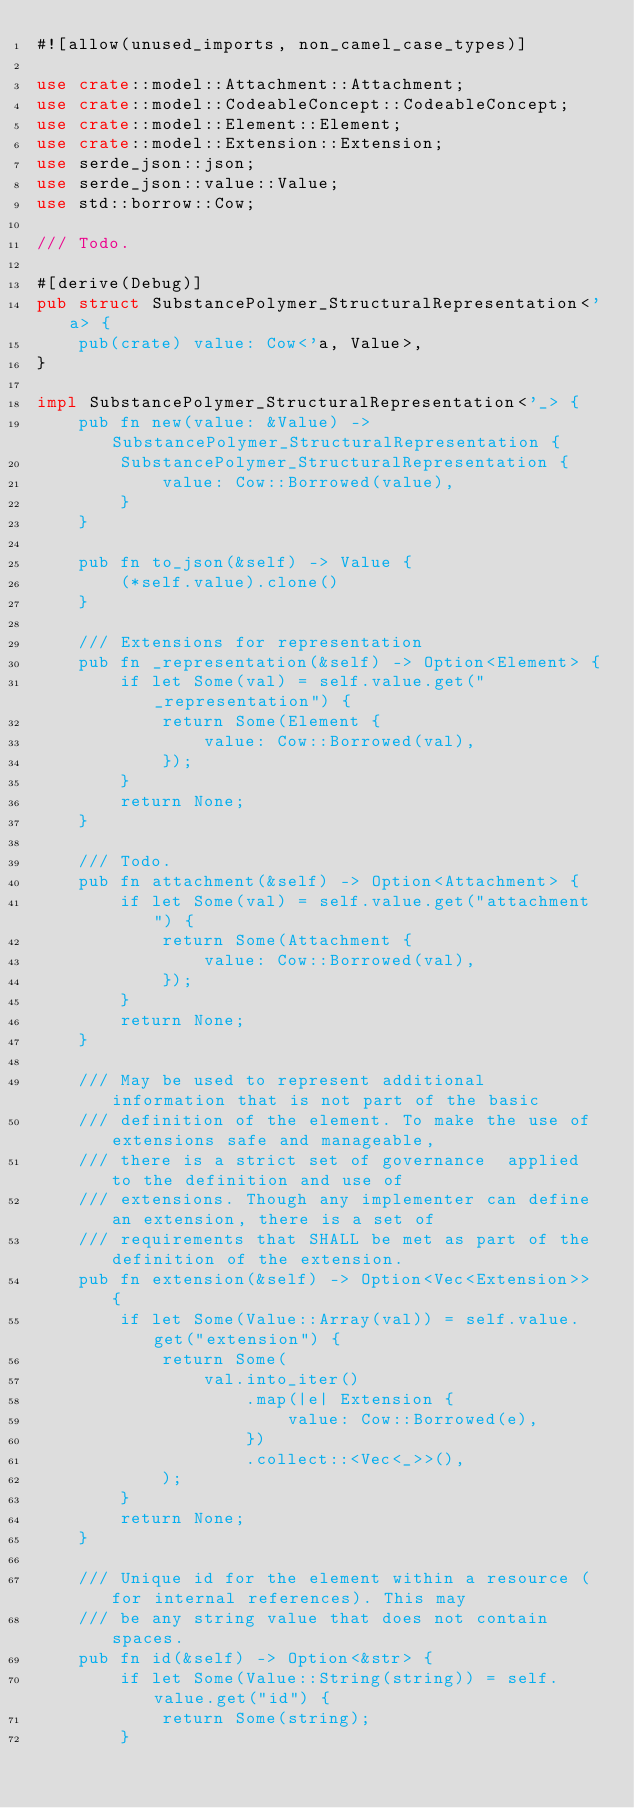Convert code to text. <code><loc_0><loc_0><loc_500><loc_500><_Rust_>#![allow(unused_imports, non_camel_case_types)]

use crate::model::Attachment::Attachment;
use crate::model::CodeableConcept::CodeableConcept;
use crate::model::Element::Element;
use crate::model::Extension::Extension;
use serde_json::json;
use serde_json::value::Value;
use std::borrow::Cow;

/// Todo.

#[derive(Debug)]
pub struct SubstancePolymer_StructuralRepresentation<'a> {
    pub(crate) value: Cow<'a, Value>,
}

impl SubstancePolymer_StructuralRepresentation<'_> {
    pub fn new(value: &Value) -> SubstancePolymer_StructuralRepresentation {
        SubstancePolymer_StructuralRepresentation {
            value: Cow::Borrowed(value),
        }
    }

    pub fn to_json(&self) -> Value {
        (*self.value).clone()
    }

    /// Extensions for representation
    pub fn _representation(&self) -> Option<Element> {
        if let Some(val) = self.value.get("_representation") {
            return Some(Element {
                value: Cow::Borrowed(val),
            });
        }
        return None;
    }

    /// Todo.
    pub fn attachment(&self) -> Option<Attachment> {
        if let Some(val) = self.value.get("attachment") {
            return Some(Attachment {
                value: Cow::Borrowed(val),
            });
        }
        return None;
    }

    /// May be used to represent additional information that is not part of the basic
    /// definition of the element. To make the use of extensions safe and manageable,
    /// there is a strict set of governance  applied to the definition and use of
    /// extensions. Though any implementer can define an extension, there is a set of
    /// requirements that SHALL be met as part of the definition of the extension.
    pub fn extension(&self) -> Option<Vec<Extension>> {
        if let Some(Value::Array(val)) = self.value.get("extension") {
            return Some(
                val.into_iter()
                    .map(|e| Extension {
                        value: Cow::Borrowed(e),
                    })
                    .collect::<Vec<_>>(),
            );
        }
        return None;
    }

    /// Unique id for the element within a resource (for internal references). This may
    /// be any string value that does not contain spaces.
    pub fn id(&self) -> Option<&str> {
        if let Some(Value::String(string)) = self.value.get("id") {
            return Some(string);
        }</code> 